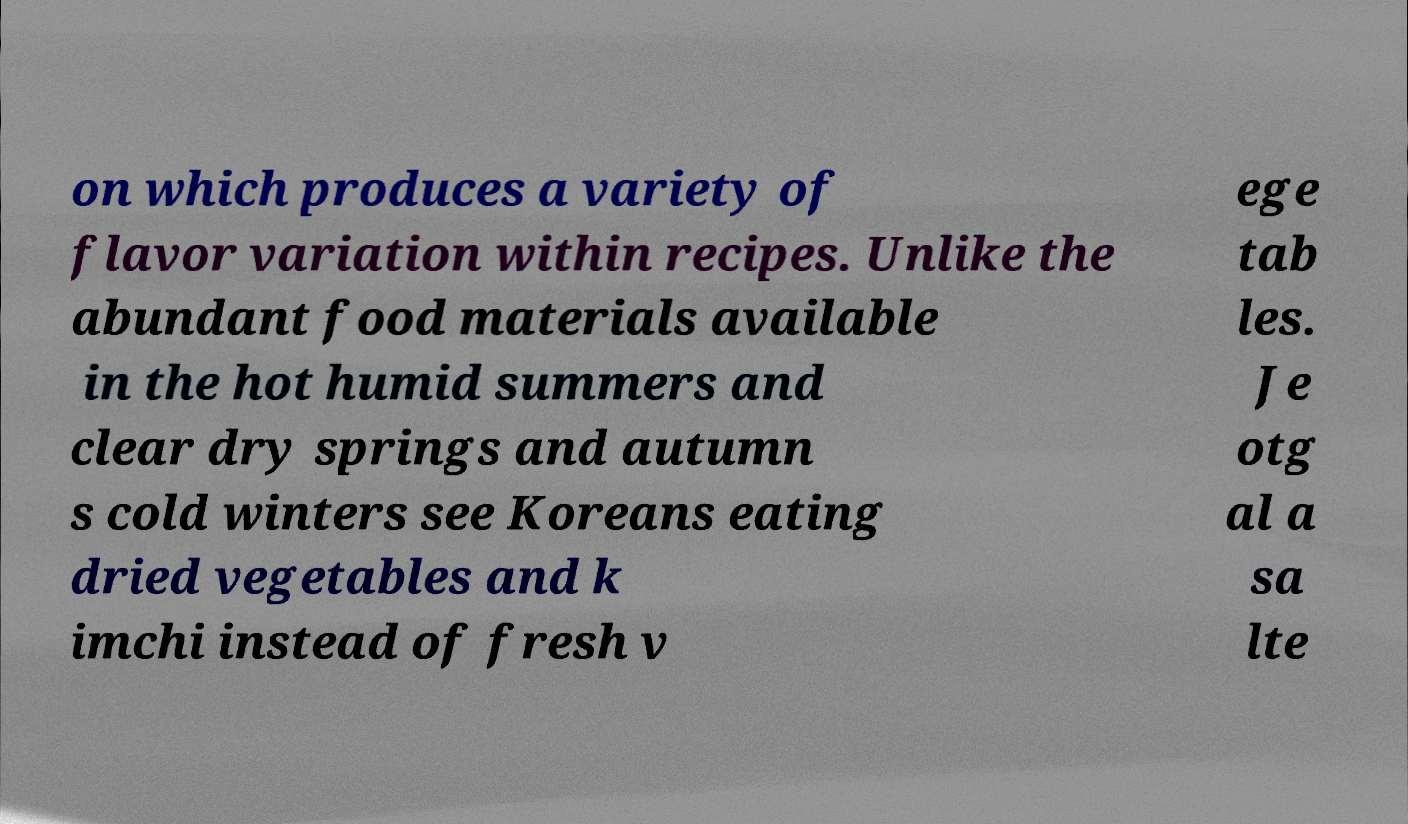What messages or text are displayed in this image? I need them in a readable, typed format. on which produces a variety of flavor variation within recipes. Unlike the abundant food materials available in the hot humid summers and clear dry springs and autumn s cold winters see Koreans eating dried vegetables and k imchi instead of fresh v ege tab les. Je otg al a sa lte 